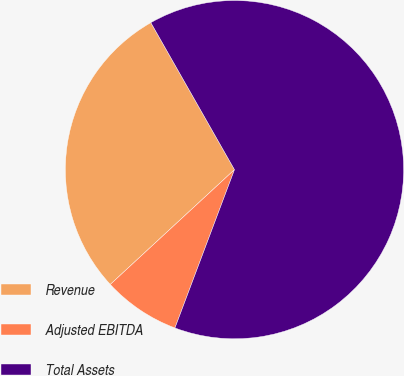<chart> <loc_0><loc_0><loc_500><loc_500><pie_chart><fcel>Revenue<fcel>Adjusted EBITDA<fcel>Total Assets<nl><fcel>28.64%<fcel>7.4%<fcel>63.95%<nl></chart> 